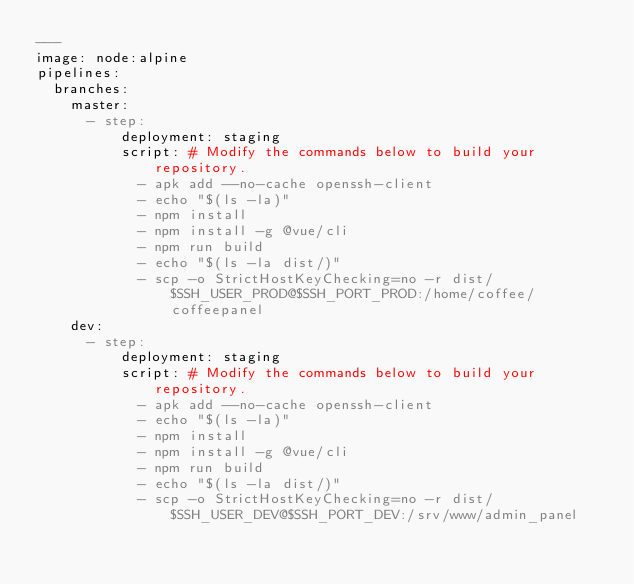Convert code to text. <code><loc_0><loc_0><loc_500><loc_500><_YAML_>---
image: node:alpine
pipelines:
  branches:
    master:
      - step:
          deployment: staging
          script: # Modify the commands below to build your repository.
            - apk add --no-cache openssh-client
            - echo "$(ls -la)"
            - npm install
            - npm install -g @vue/cli
            - npm run build
            - echo "$(ls -la dist/)"
            - scp -o StrictHostKeyChecking=no -r dist/ $SSH_USER_PROD@$SSH_PORT_PROD:/home/coffee/coffeepanel
    dev:
      - step:
          deployment: staging
          script: # Modify the commands below to build your repository.
            - apk add --no-cache openssh-client
            - echo "$(ls -la)"
            - npm install
            - npm install -g @vue/cli
            - npm run build
            - echo "$(ls -la dist/)"
            - scp -o StrictHostKeyChecking=no -r dist/ $SSH_USER_DEV@$SSH_PORT_DEV:/srv/www/admin_panel</code> 